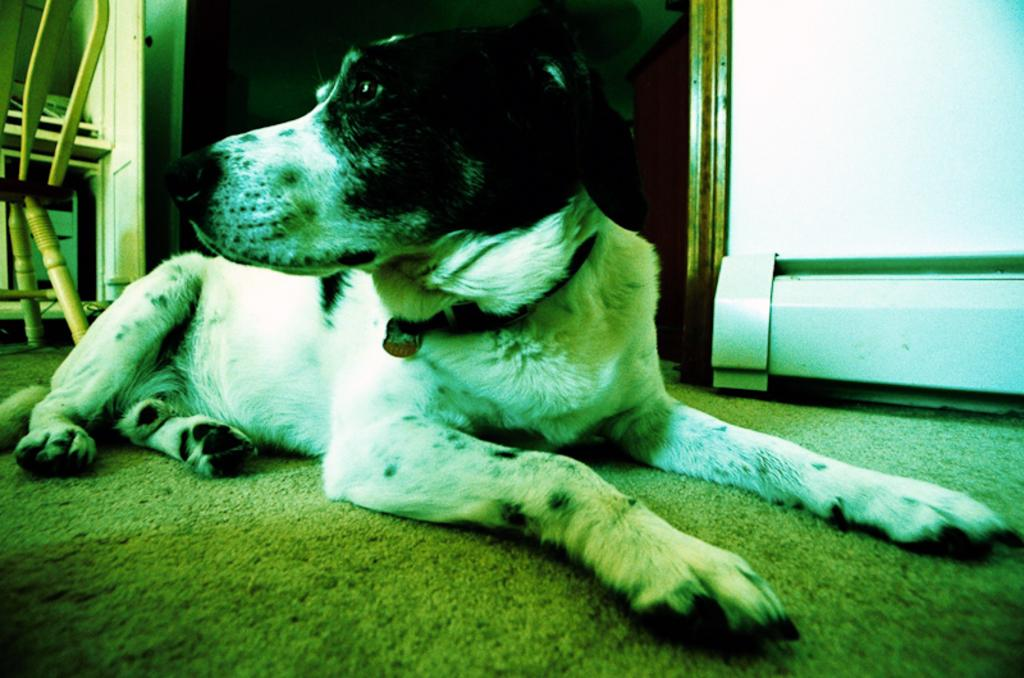What animal can be seen in the image? There is a dog in the image. Where is the dog sitting? The dog is sitting on a carpet. What is the carpet placed on? The carpet is on the floor. What can be seen in the background of the image? There is a wall, a chair, and other objects visible in the background of the image. How many kittens are playing with the liquid in the image? There are no kittens or liquid present in the image. 